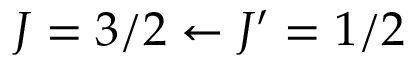<formula> <loc_0><loc_0><loc_500><loc_500>J = 3 / 2 \leftarrow J ^ { \prime } = 1 / 2</formula> 